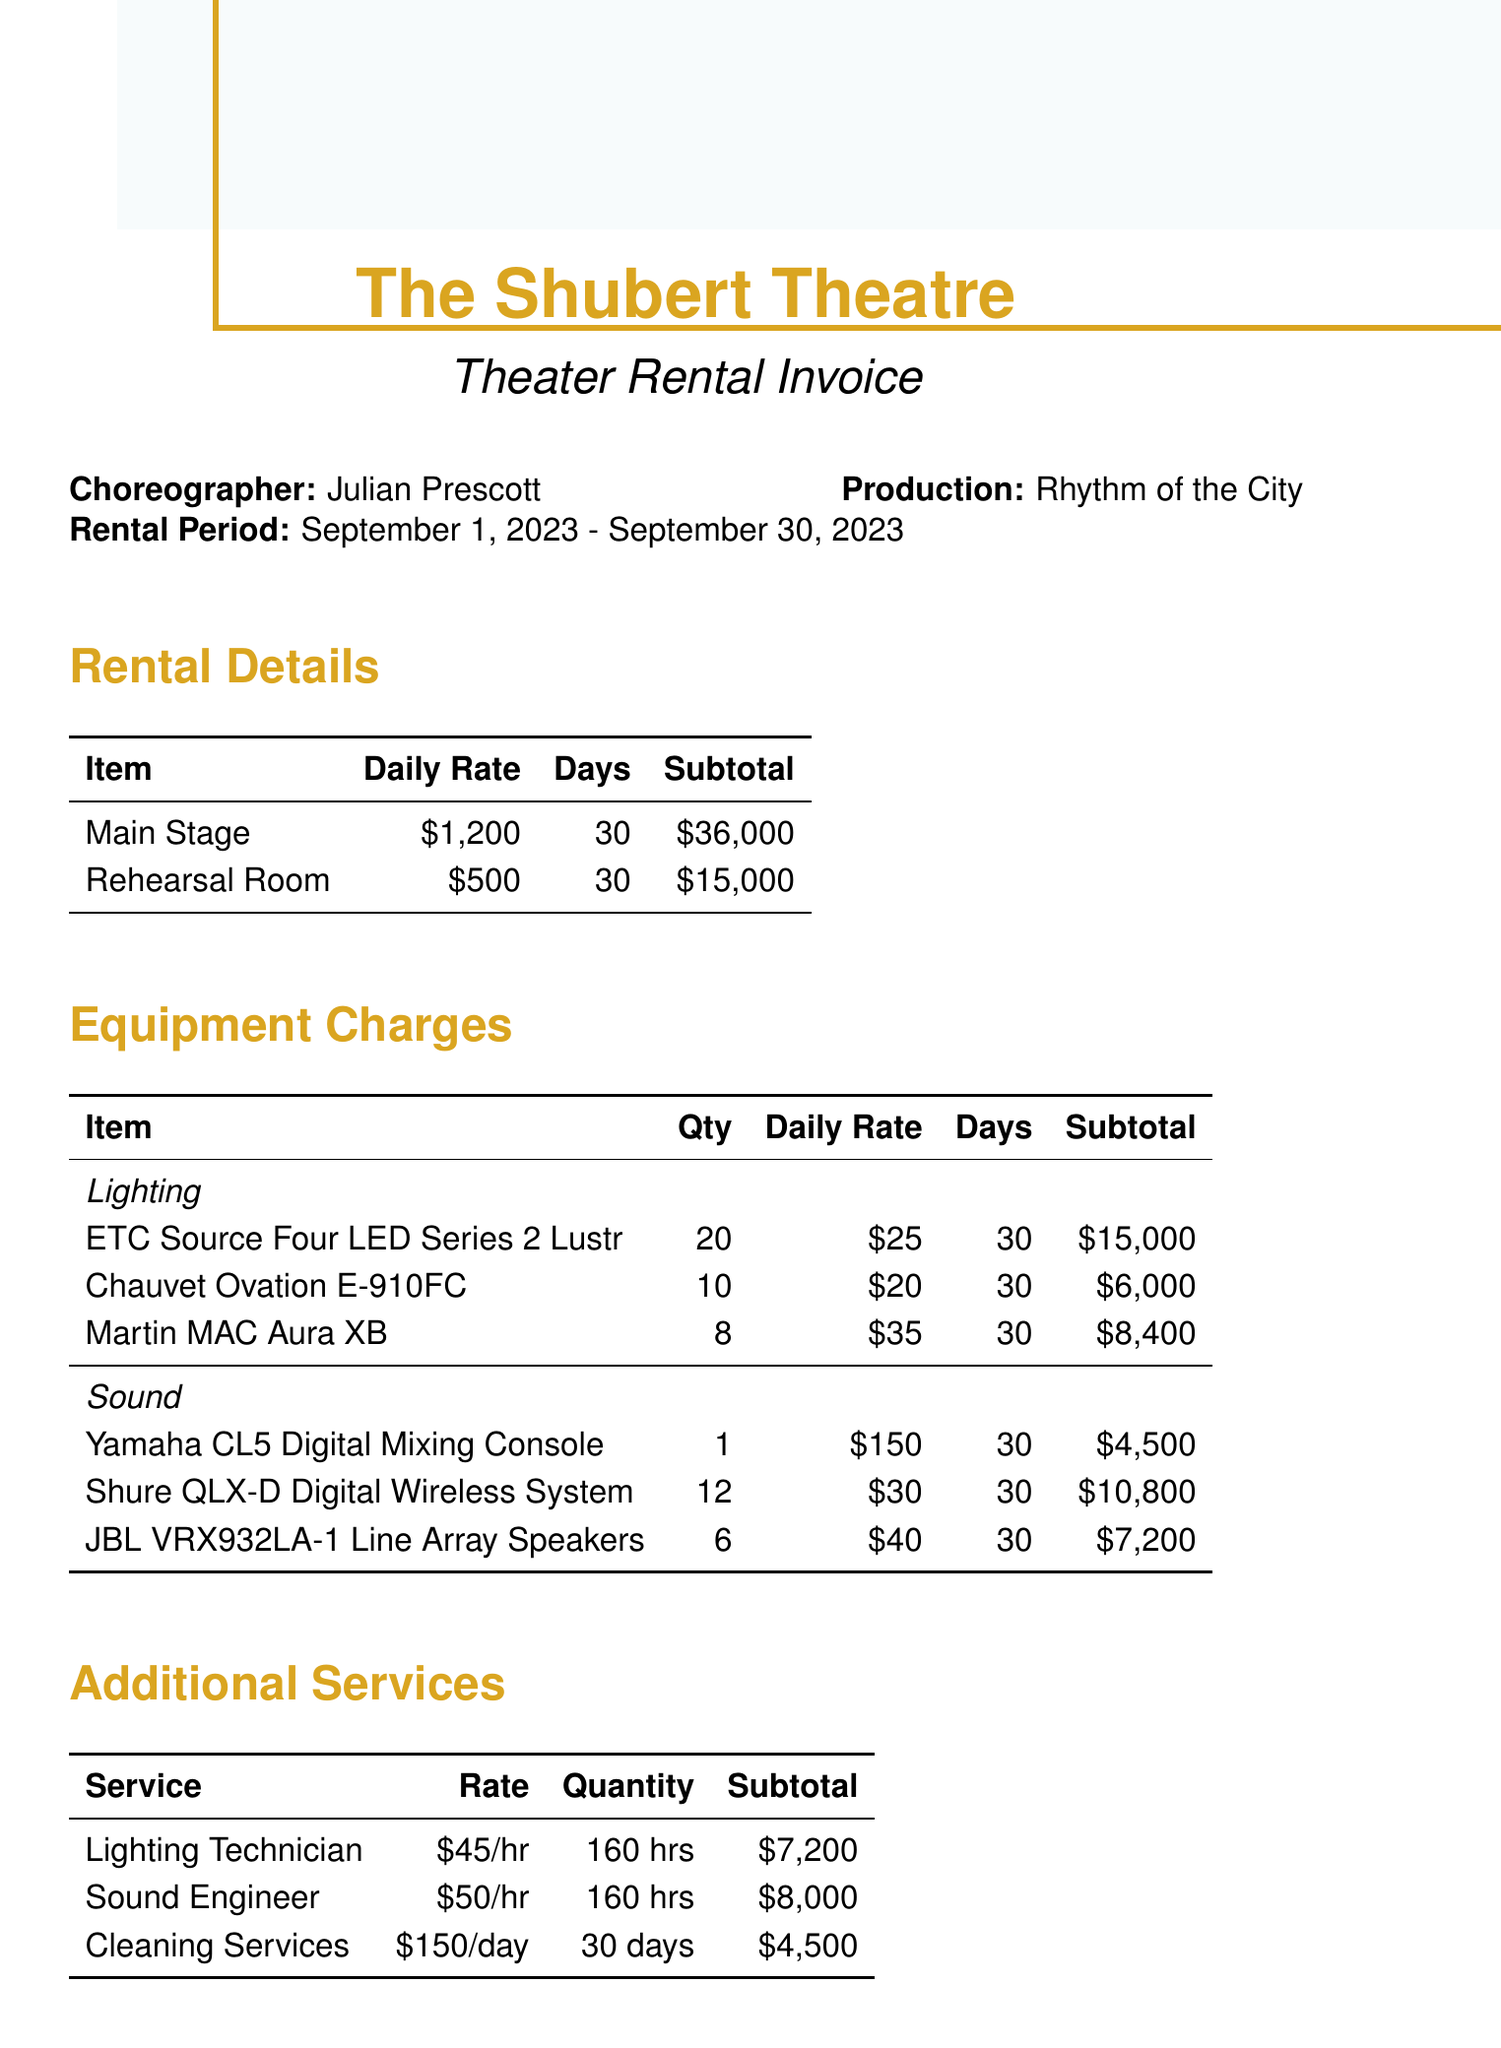what is the name of the theater? The name of the theater, as mentioned in the document, is "The Shubert Theatre."
Answer: The Shubert Theatre who is the choreographer? The choreographer's name listed in the document is "Julian Prescott."
Answer: Julian Prescott what is the total amount charged for the main stage rental? The subtotal for the main stage rental is provided as $36,000.
Answer: $36,000 how many days was the rehearsal period? The rental period consists of a start date and end date spanning 30 days in September.
Answer: 30 days what is the daily rate for the rehearsal room? The document specifies the daily rate for the rehearsal room as $500.
Answer: $500 what is the subtotal for lighting equipment? The subtotal for all lighting equipment charges combined is given as $29,400, which includes several items.
Answer: $29,400 who is the contact person for the theater? The contact person listed for the theater is "Sarah Thompson."
Answer: Sarah Thompson what are the total hours billed for technician support? The total hours for technician support mentioned are 160 hours each for the lighting technician and sound engineer.
Answer: 160 hours what are the payment terms specified in the document? The payment terms involve a deposit of 50% upon booking and the balance due on the last day of the rental period.
Answer: 50% due upon booking, remaining 50% due on the last day 